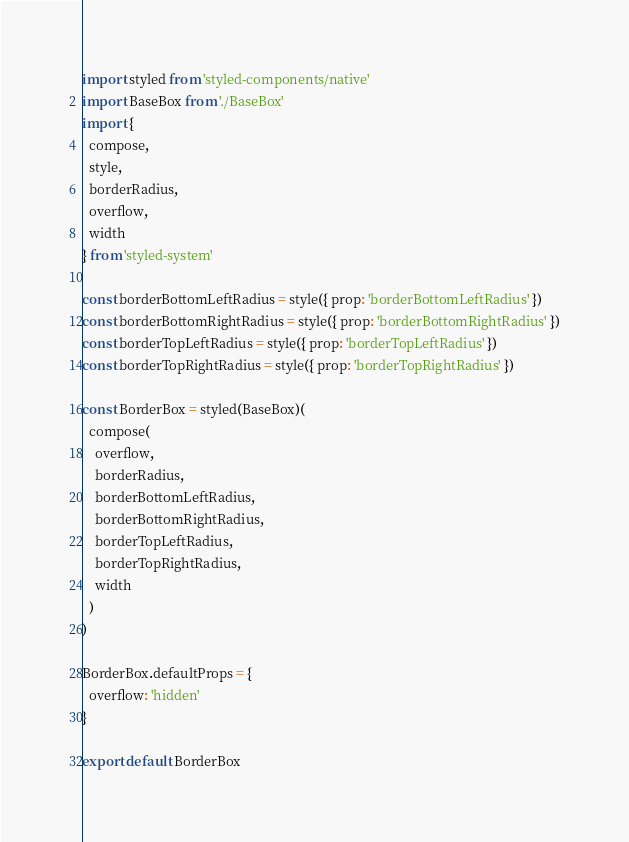Convert code to text. <code><loc_0><loc_0><loc_500><loc_500><_JavaScript_>import styled from 'styled-components/native'
import BaseBox from './BaseBox'
import {
  compose,
  style,
  borderRadius,
  overflow,
  width
} from 'styled-system'

const borderBottomLeftRadius = style({ prop: 'borderBottomLeftRadius' })
const borderBottomRightRadius = style({ prop: 'borderBottomRightRadius' })
const borderTopLeftRadius = style({ prop: 'borderTopLeftRadius' })
const borderTopRightRadius = style({ prop: 'borderTopRightRadius' })

const BorderBox = styled(BaseBox)(
  compose(
    overflow,
    borderRadius,
    borderBottomLeftRadius,
    borderBottomRightRadius,
    borderTopLeftRadius,
    borderTopRightRadius,
    width
  )
)

BorderBox.defaultProps = {
  overflow: 'hidden'
}

export default BorderBox
</code> 